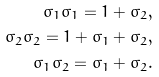<formula> <loc_0><loc_0><loc_500><loc_500>\sigma _ { 1 } \sigma _ { 1 } = 1 + \sigma _ { 2 } , \\ \sigma _ { 2 } \sigma _ { 2 } = 1 + \sigma _ { 1 } + \sigma _ { 2 } , \\ \sigma _ { 1 } \sigma _ { 2 } = \sigma _ { 1 } + \sigma _ { 2 } .</formula> 